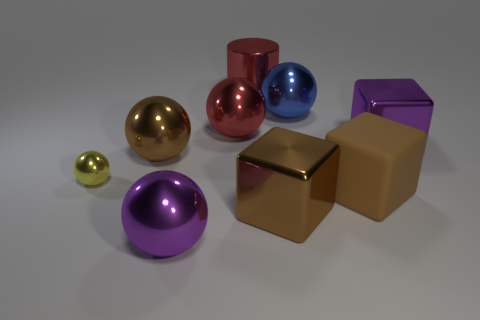Subtract all large metallic blocks. How many blocks are left? 1 Subtract all cubes. How many objects are left? 6 Add 1 matte cylinders. How many objects exist? 10 Subtract all purple blocks. How many blocks are left? 2 Subtract all blue objects. Subtract all brown rubber things. How many objects are left? 7 Add 8 big red shiny cylinders. How many big red shiny cylinders are left? 9 Add 4 large purple metallic cubes. How many large purple metallic cubes exist? 5 Subtract 0 green blocks. How many objects are left? 9 Subtract 1 cubes. How many cubes are left? 2 Subtract all yellow blocks. Subtract all yellow balls. How many blocks are left? 3 